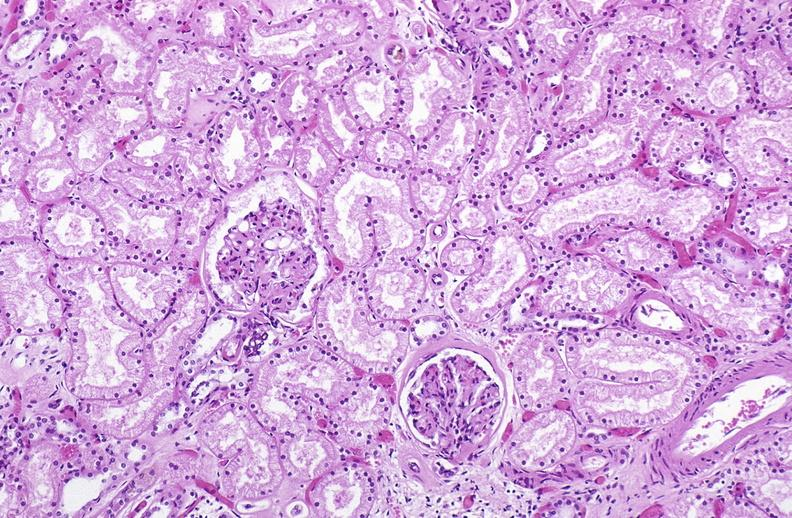s urinary present?
Answer the question using a single word or phrase. Yes 